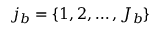<formula> <loc_0><loc_0><loc_500><loc_500>j _ { b } = \{ 1 , 2 , \dots , J _ { b } \}</formula> 